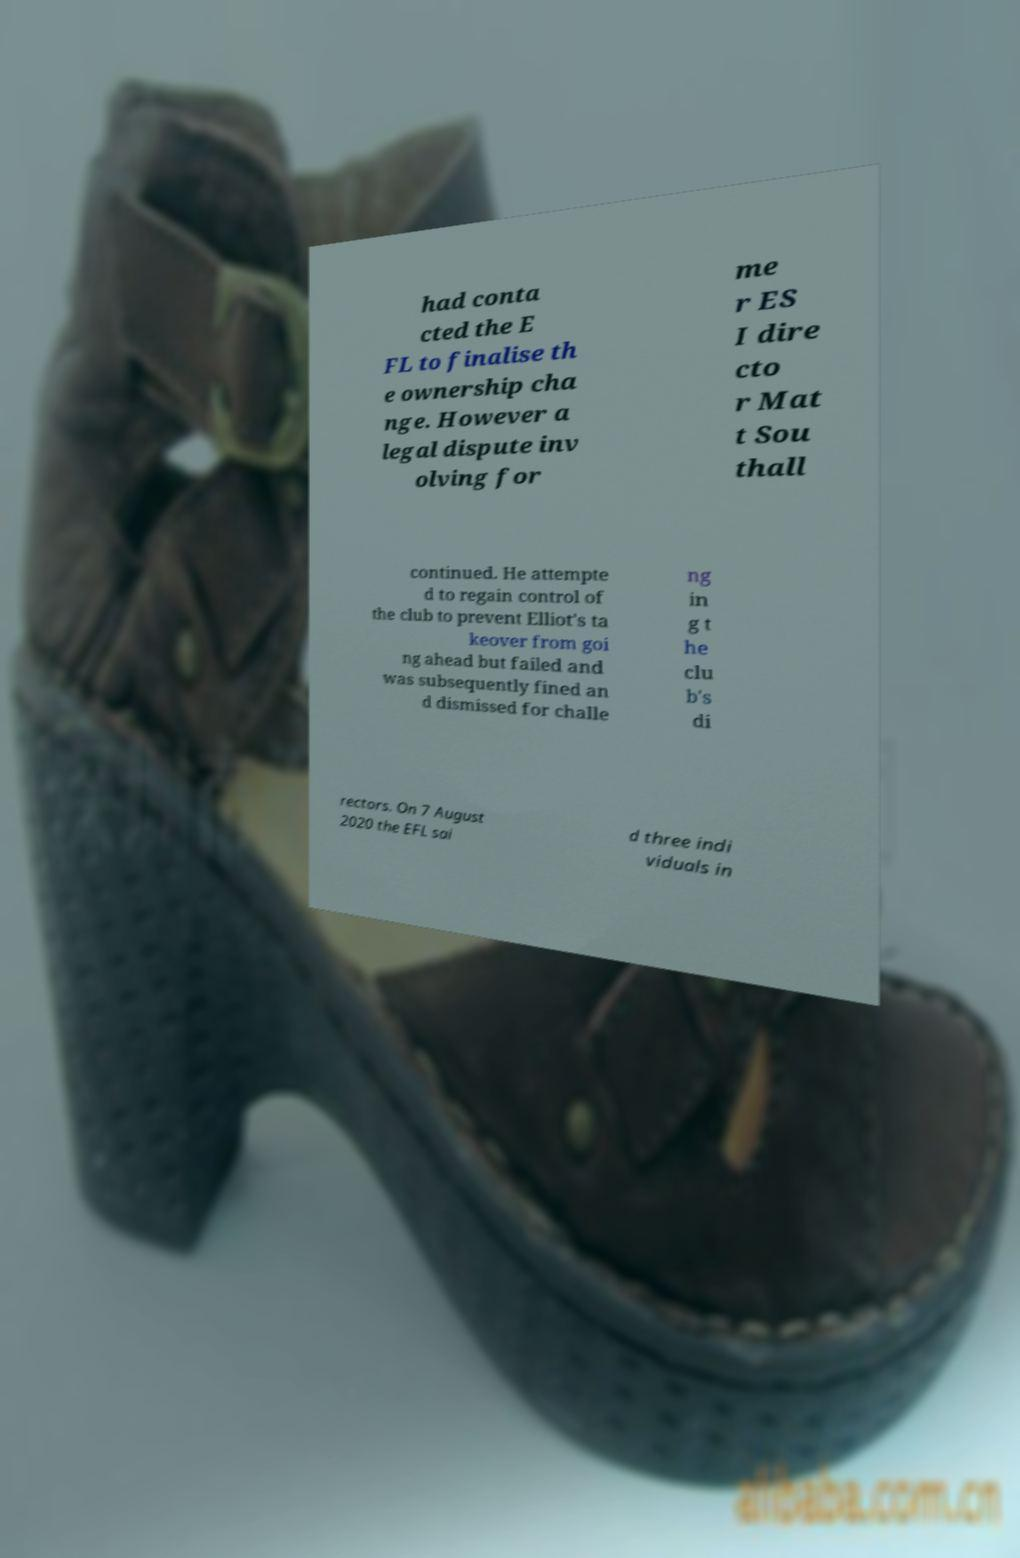There's text embedded in this image that I need extracted. Can you transcribe it verbatim? had conta cted the E FL to finalise th e ownership cha nge. However a legal dispute inv olving for me r ES I dire cto r Mat t Sou thall continued. He attempte d to regain control of the club to prevent Elliot's ta keover from goi ng ahead but failed and was subsequently fined an d dismissed for challe ng in g t he clu b's di rectors. On 7 August 2020 the EFL sai d three indi viduals in 